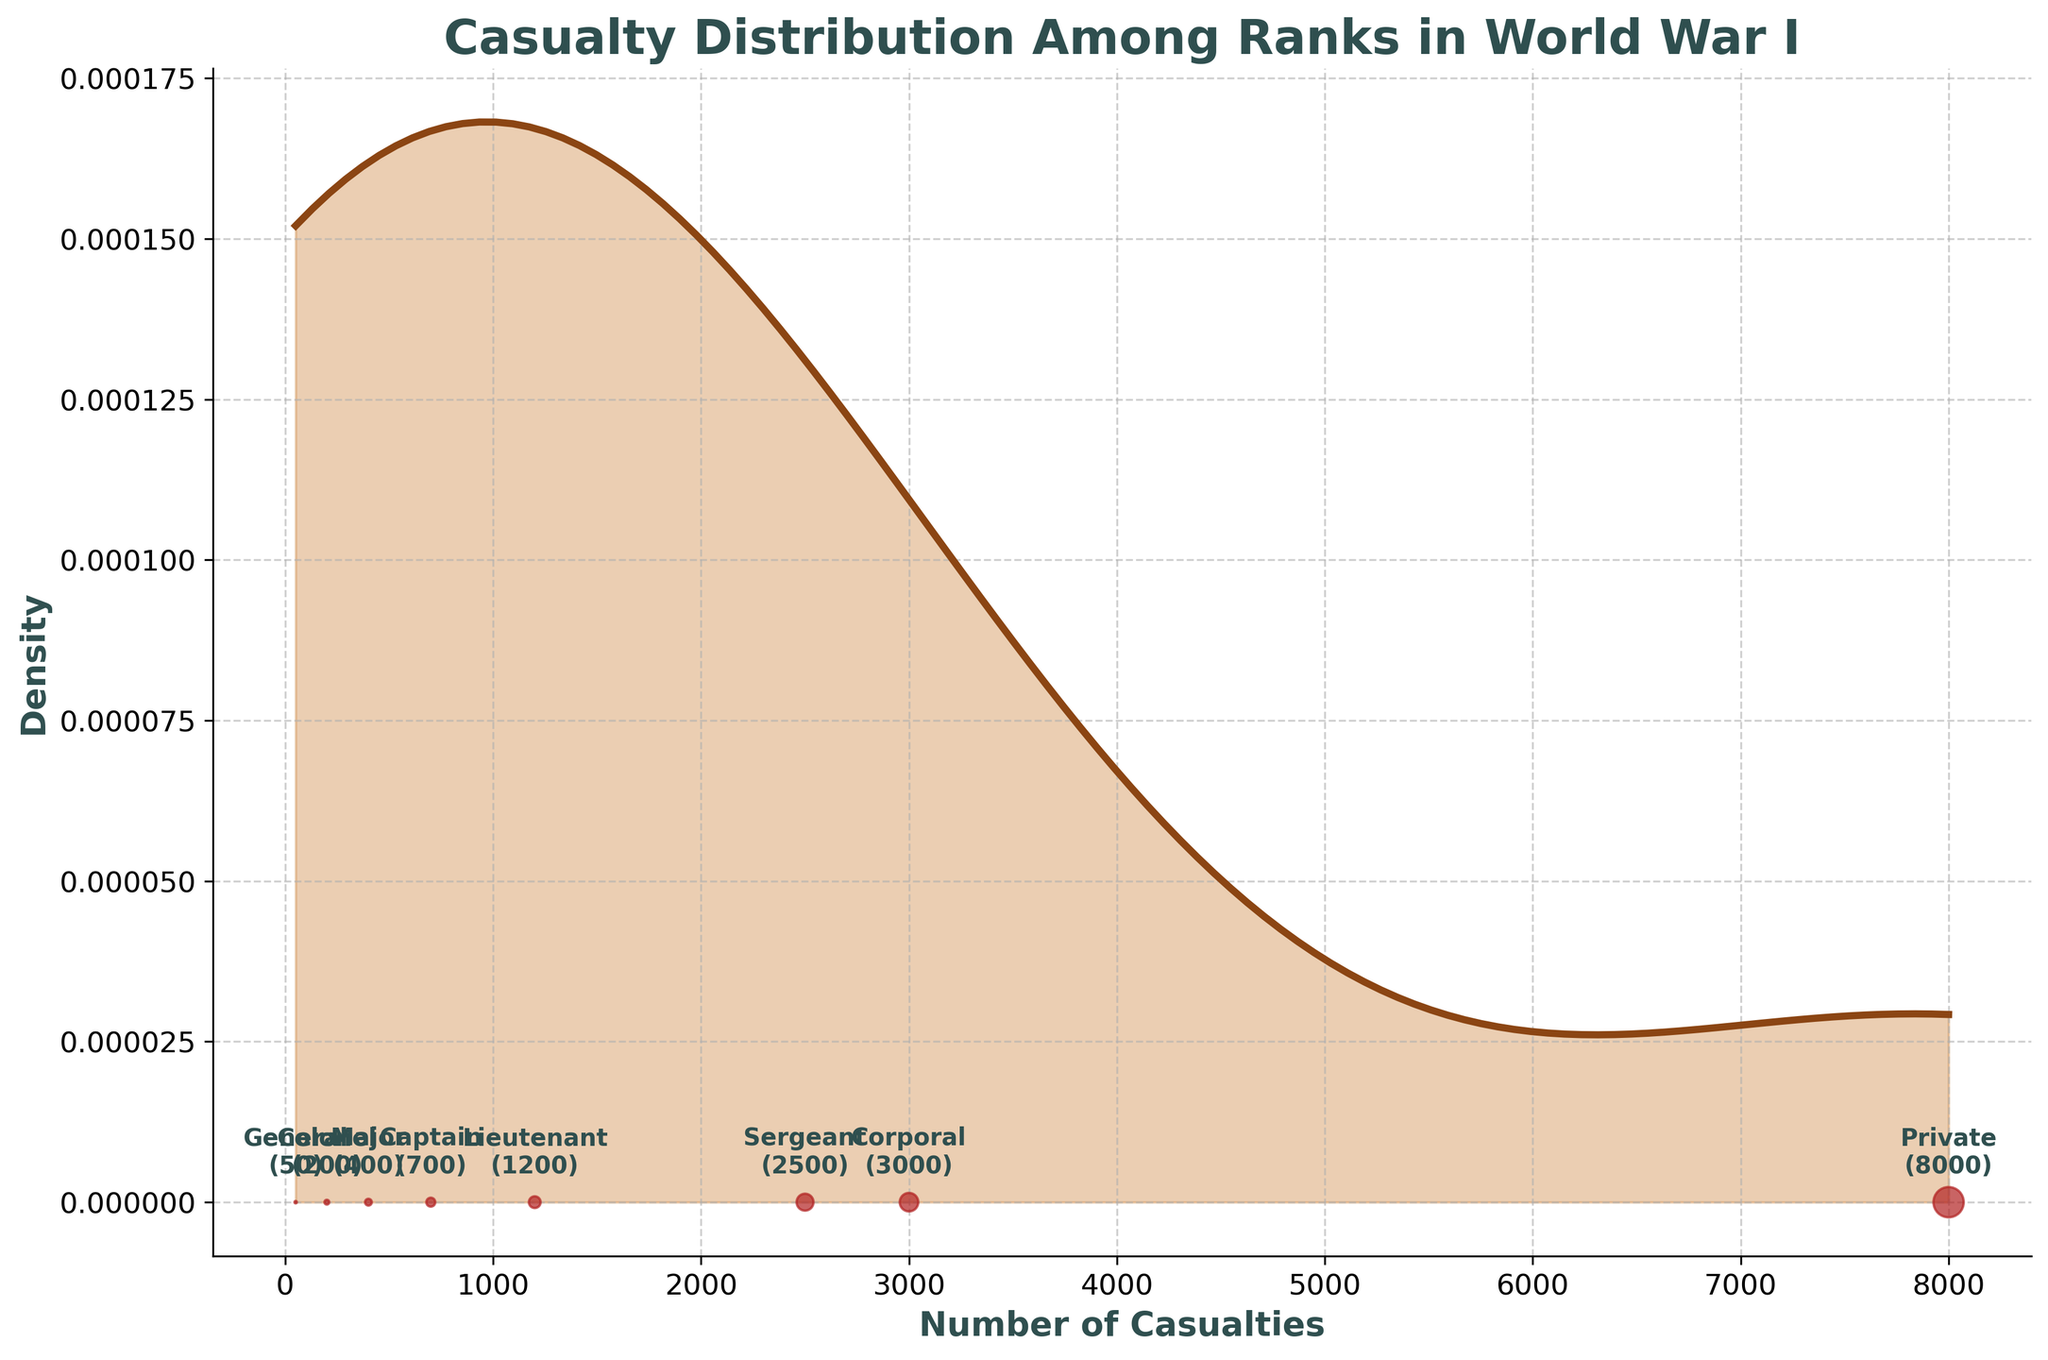Which rank has the highest number of casualties? The figure shows scatter points annotated with the rank names and their casualty counts. The rank with the highest number is clearly labeled.
Answer: Private What's the title of the figure? The title of the figure is placed at the top center and is in bold text. It succinctly describes the content of the figure.
Answer: Casualty Distribution Among Ranks in World War I How many ranks have average casualty numbers between Sergeant and General? The figure shows the casualty numbers annotated next to each scatter point. We need to count the ranks whose casualty numbers fall between the range specified.
Answer: Five (Lieutenant, Captain, Major, Colonel, General) Is the density of casualties higher for junior or senior ranks? By observing the density plot, the peak and spread can indicate where the densities are. Higher peaks and wider spreads imply higher densities.
Answer: Junior ranks Which two consecutive ranks have the largest difference in casualties? We compare the annotated casualty numbers for each rank and identify the pair with the maximum difference.
Answer: Private and Corporal Between which two ranks is the density curve the steepest? The steepness of the density curve is identified by the sharp changes in the y-axis value within a small range of x-axis values, visible in the density plot.
Answer: Corporal and Sergeant What's the approximate number of casualties for Captains? The figure has scatter points annotated with exact casualty numbers next to each rank, making it clear.
Answer: 700 Are there any ranks with less than 500 casualties? By examining the annotated scatter points, we can identify if there are any ranks with visible indications of less than 500 casualties.
Answer: Yes Which rank has 2500 casualties? The figure labels each data point with the corresponding rank and number of casualties. By finding the label with 2500, we can identify the rank.
Answer: Sergeant What color represents the scatter points in the figure? The color of the scatter points is distinctly visible and stands out against the other elements in the plot.
Answer: Red 